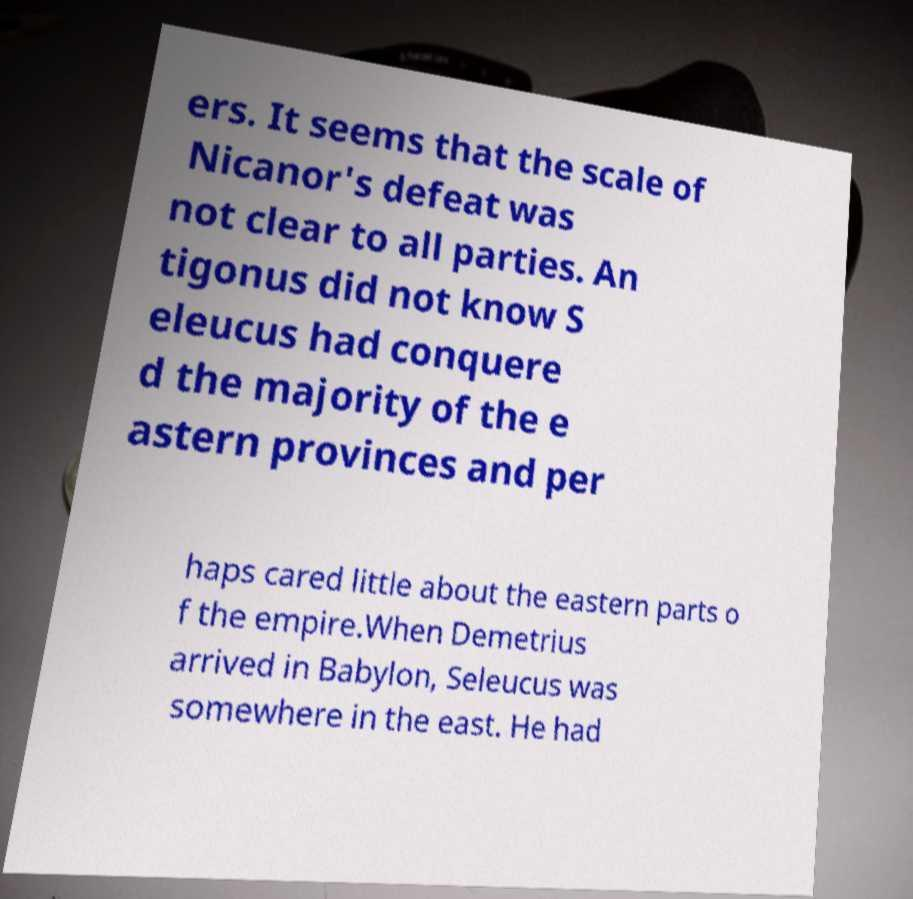Could you assist in decoding the text presented in this image and type it out clearly? ers. It seems that the scale of Nicanor's defeat was not clear to all parties. An tigonus did not know S eleucus had conquere d the majority of the e astern provinces and per haps cared little about the eastern parts o f the empire.When Demetrius arrived in Babylon, Seleucus was somewhere in the east. He had 